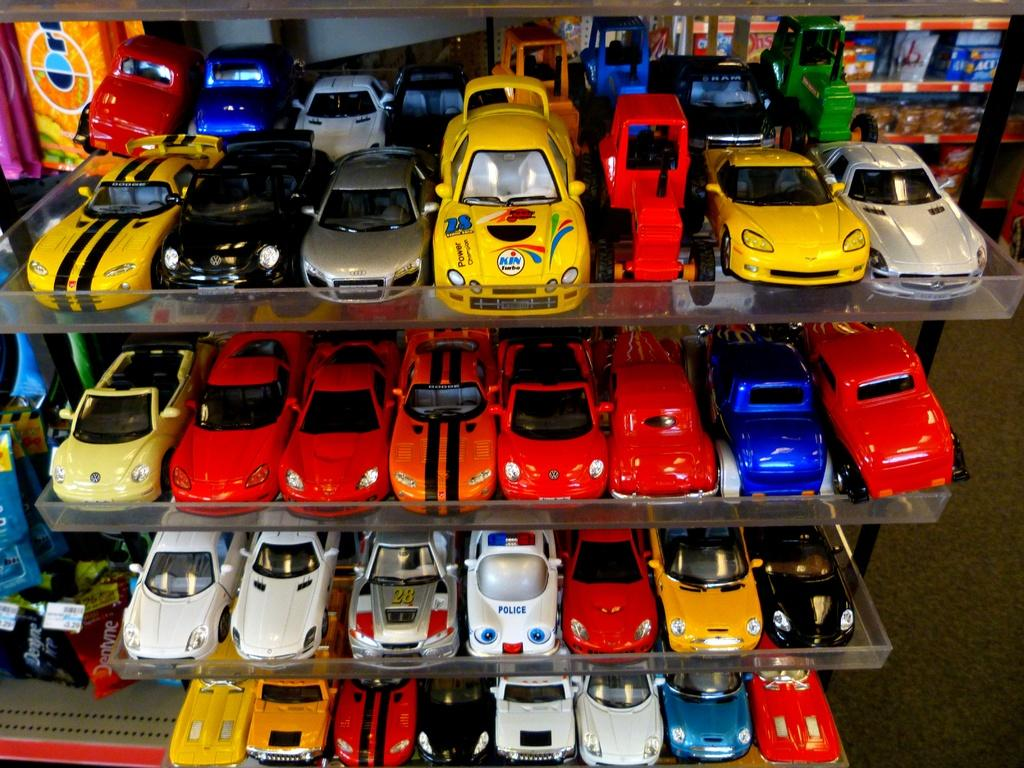What type of toys can be seen in the image? There are toy cars in the image. How are the toy cars arranged or stored in the image? The toy cars are kept on plastic racks. What type of quill is used to write the names of the toy cars on the plastic racks? There is no quill or writing present in the image; the toy cars are simply stored on the plastic racks. 